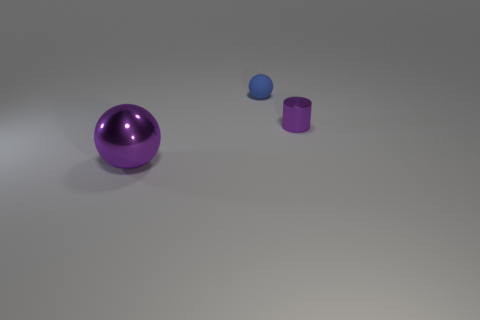Add 1 large purple balls. How many objects exist? 4 Subtract all balls. How many objects are left? 1 Subtract all tiny blue objects. Subtract all large red rubber balls. How many objects are left? 2 Add 2 purple cylinders. How many purple cylinders are left? 3 Add 2 purple cylinders. How many purple cylinders exist? 3 Subtract 0 green cubes. How many objects are left? 3 